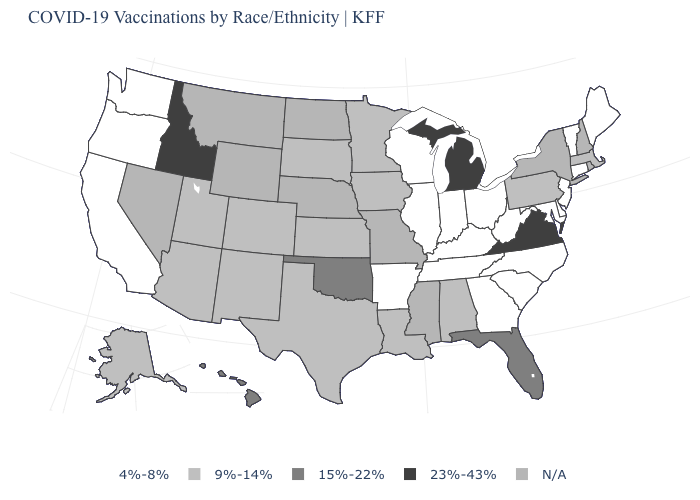What is the value of New Jersey?
Be succinct. 4%-8%. What is the value of Virginia?
Quick response, please. 23%-43%. What is the value of Michigan?
Concise answer only. 23%-43%. Which states have the highest value in the USA?
Quick response, please. Idaho, Michigan, Virginia. Does Wisconsin have the lowest value in the USA?
Write a very short answer. Yes. What is the highest value in the West ?
Short answer required. 23%-43%. What is the value of Maine?
Short answer required. 4%-8%. Does Michigan have the highest value in the USA?
Be succinct. Yes. Name the states that have a value in the range N/A?
Quick response, please. Mississippi, Missouri, Montana, Nebraska, Nevada, New Hampshire, New York, North Dakota, Rhode Island, Wyoming. Name the states that have a value in the range 9%-14%?
Keep it brief. Alabama, Alaska, Arizona, Colorado, Iowa, Kansas, Louisiana, Massachusetts, Minnesota, New Mexico, Pennsylvania, South Dakota, Texas, Utah. What is the highest value in the USA?
Answer briefly. 23%-43%. What is the value of Nevada?
Concise answer only. N/A. What is the highest value in states that border Arizona?
Answer briefly. 9%-14%. Name the states that have a value in the range 4%-8%?
Write a very short answer. Arkansas, California, Connecticut, Delaware, Georgia, Illinois, Indiana, Kentucky, Maine, Maryland, New Jersey, North Carolina, Ohio, Oregon, South Carolina, Tennessee, Vermont, Washington, West Virginia, Wisconsin. 